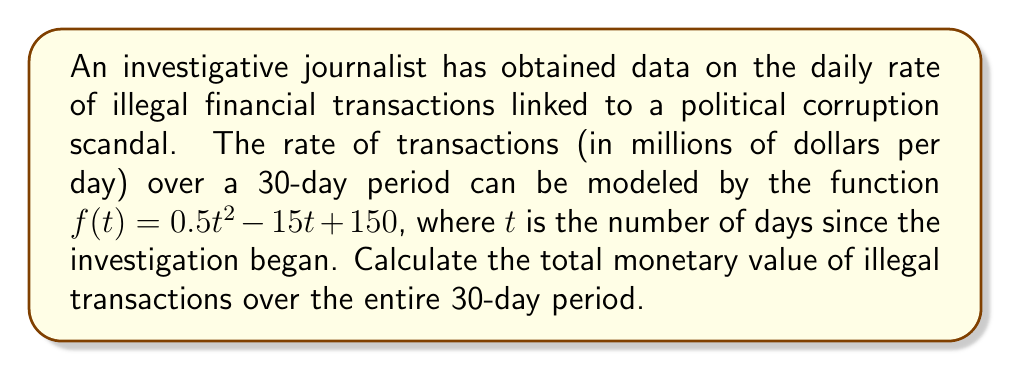Show me your answer to this math problem. To solve this problem, we need to use a definite integral to calculate the total monetary value of illegal transactions over the 30-day period. The steps are as follows:

1) The function $f(t) = 0.5t^2 - 15t + 150$ represents the rate of transactions in millions of dollars per day.

2) To find the total value over the 30-day period, we need to integrate this function from $t=0$ to $t=30$.

3) Set up the definite integral:

   $$\int_0^{30} (0.5t^2 - 15t + 150) dt$$

4) Integrate the function:
   
   $$\left[\frac{1}{6}t^3 - \frac{15}{2}t^2 + 150t\right]_0^{30}$$

5) Evaluate the integral:

   $$\left(\frac{1}{6}(30^3) - \frac{15}{2}(30^2) + 150(30)\right) - \left(\frac{1}{6}(0^3) - \frac{15}{2}(0^2) + 150(0)\right)$$

6) Simplify:

   $$\left(4500 - 6750 + 4500\right) - 0 = 2250$$

7) The result is in millions of dollars, so the total value is $2250 million or $2.25 billion.
Answer: $2.25 billion 